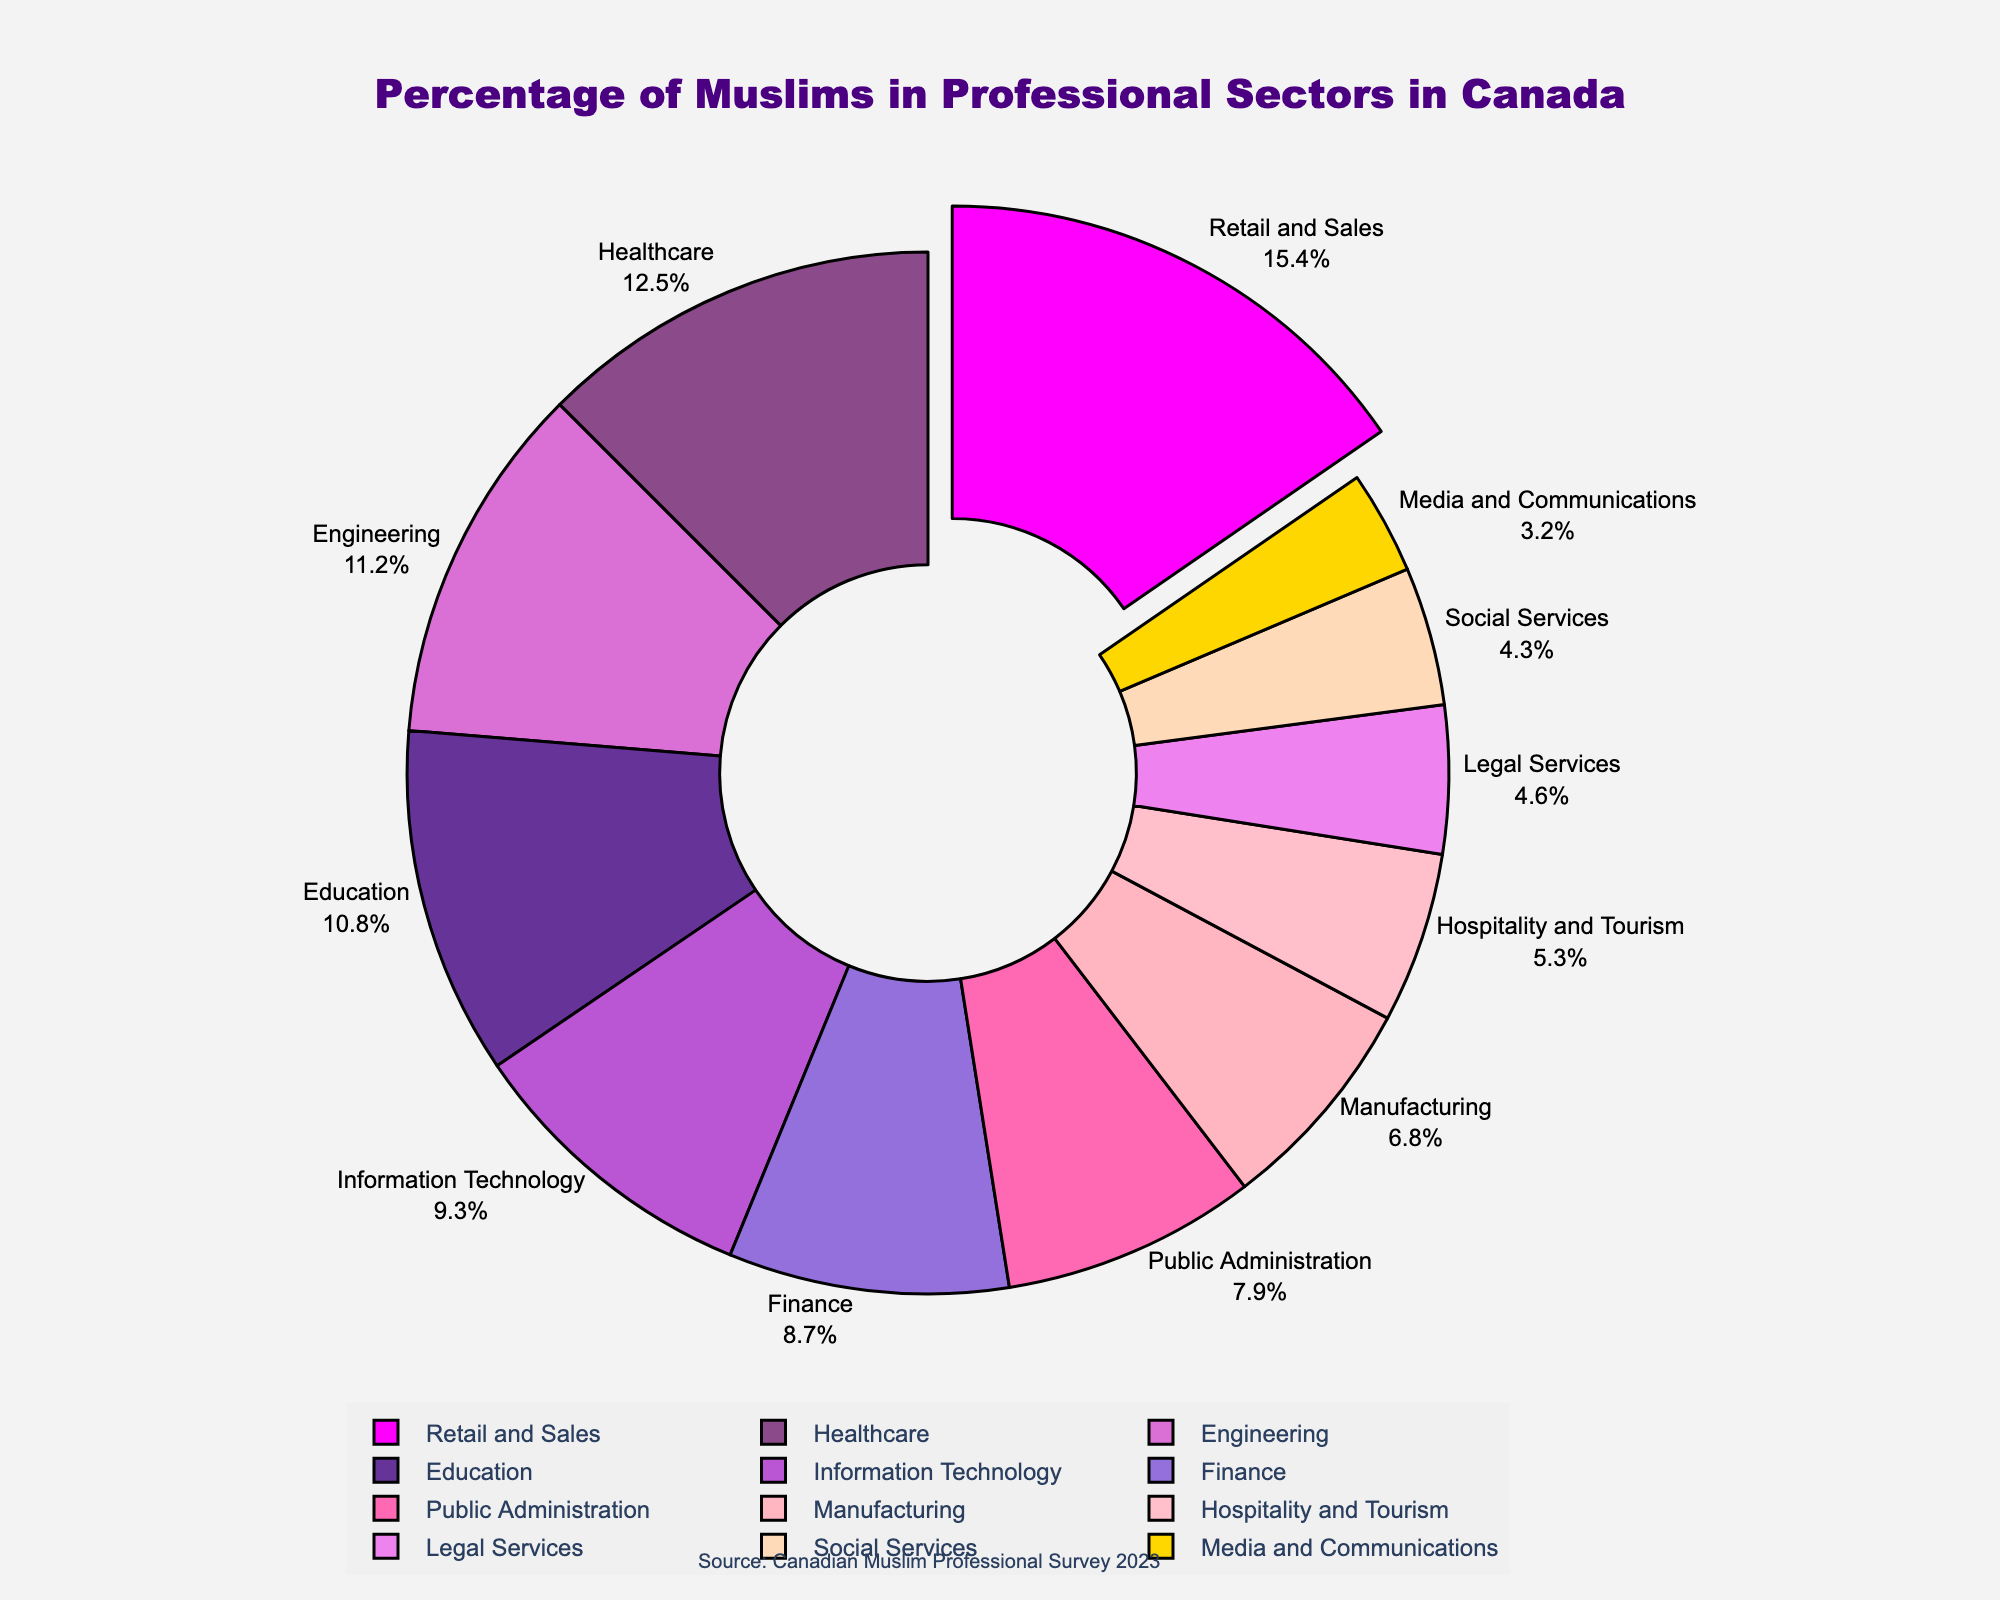What sector has the highest percentage of Muslims? By looking at the pie chart, the largest slice represents the sector with the highest percentage, which is Retail and Sales.
Answer: Retail and Sales What is the combined percentage of Muslims in Healthcare and Education sectors? The values for the Healthcare and Education sectors are 12.5% and 10.8% respectively. Adding these together, we get 12.5 + 10.8 = 23.3%.
Answer: 23.3% Which sector has a lower percentage of Muslims: Legal Services or Social Services? By comparing the slices for Legal Services (4.6%) and Social Services (4.3%), it is clear that Social Services has a lower percentage.
Answer: Social Services What is the percentage difference between Muslims in Information Technology and Finance sectors? The values for Information Technology and Finance are 9.3% and 8.7% respectively. Subtracting these values gives 9.3 - 8.7 = 0.6%.
Answer: 0.6% Which sector has the most visually prominent slice (apart from the highlighted one)? The visually prominent slice can be determined by looking at its relative size. After the highlighted sector, the next largest slice represents Retail and Sales, followed by Healthcare.
Answer: Healthcare Are there more Muslims in Manufacturing or in Hospitality and Tourism? The percentage for Manufacturing is 6.8%, while Hospitality and Tourism is 5.3%. Therefore, there are more Muslims in Manufacturing.
Answer: Manufacturing What is the combined percentage of Muslims in sectors with less than 5% representation? Sectors with less than 5% are Legal Services (4.6%), Media and Communications (3.2%), and Social Services (4.3%). Adding these, we get 4.6 + 3.2 + 4.3 = 12.1%.
Answer: 12.1% Which sector is represented by the color gold in the pie chart? Observing the colors used in the pie chart, the sector represented by the gold color corresponds to Public Administration.
Answer: Public Administration How many sectors have a percentage greater than 10%? The sectors with percentages greater than 10% are Healthcare (12.5%), Education (10.8%), Retail and Sales (15.4%), and Engineering (11.2%). This gives a total of 4 sectors.
Answer: 4 sectors What is the average percentage of Muslims in the Legal Services, Retail and Sales, and Public Administration sectors? The values for Legal Services, Retail and Sales, and Public Administration are 4.6%, 15.4%, and 7.9% respectively. The sum is 4.6 + 15.4 + 7.9 = 27.9. Dividing by 3, the average is 27.9 / 3 = 9.3%.
Answer: 9.3% 